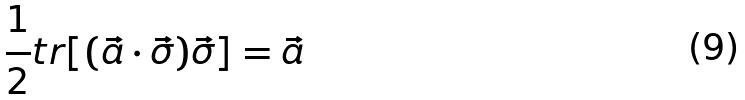Convert formula to latex. <formula><loc_0><loc_0><loc_500><loc_500>\frac { 1 } { 2 } t r [ ( \vec { a } \cdot \vec { \sigma } ) \vec { \sigma } ] = \vec { a }</formula> 